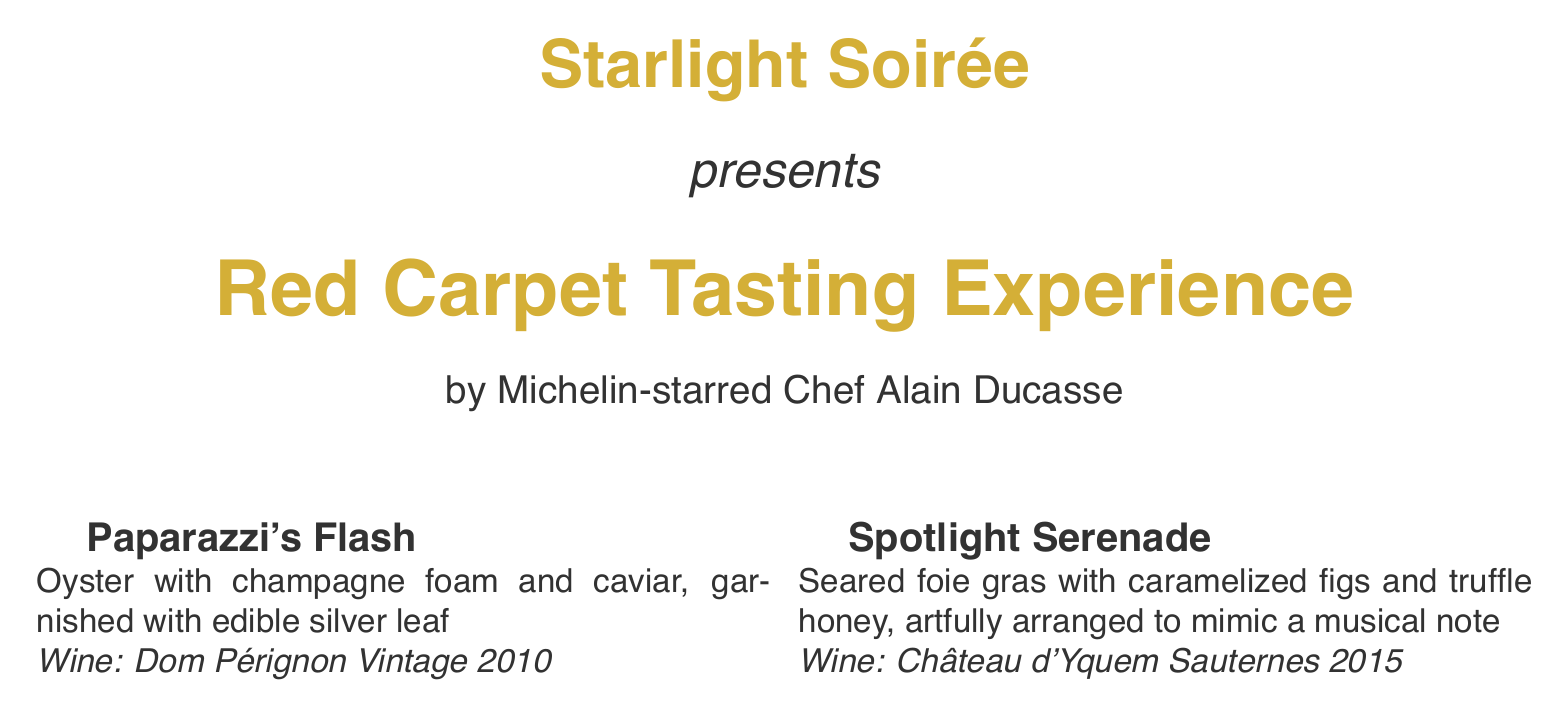What is the title of the tasting menu? The title is prominently displayed at the top of the menu.
Answer: Red Carpet Tasting Experience Who is the chef behind the tasting menu? The chef's name is mentioned next to the menu title.
Answer: Chef Alain Ducasse What is the first dish in the tasting menu? The first dish is listed in the menu's presentation.
Answer: Paparazzi's Flash What wine is paired with the Wagyu beef tenderloin? The wine pairing is specified with the corresponding dish.
Answer: Château Margaux 2010 What unique feature is included in the "Dramatic Intermission" dish? The menu describes a characteristic presentation of the dish.
Answer: Served in a hollowed-out lemon Which dish is described as having edible silver leaf? The answer is found in the description of the first dish.
Answer: Paparazzi's Flash How many dishes are included in the tasting menu? The total number can be counted from the menu items presented.
Answer: Five What type of chocolate is used in the "Standing Ovation"? The specific type of chocolate is detailed in the dish's description.
Answer: Dark chocolate What is the serving style for the dessert? The menu describes how the dessert is presented to the guest.
Answer: Dramatically melted tableside 